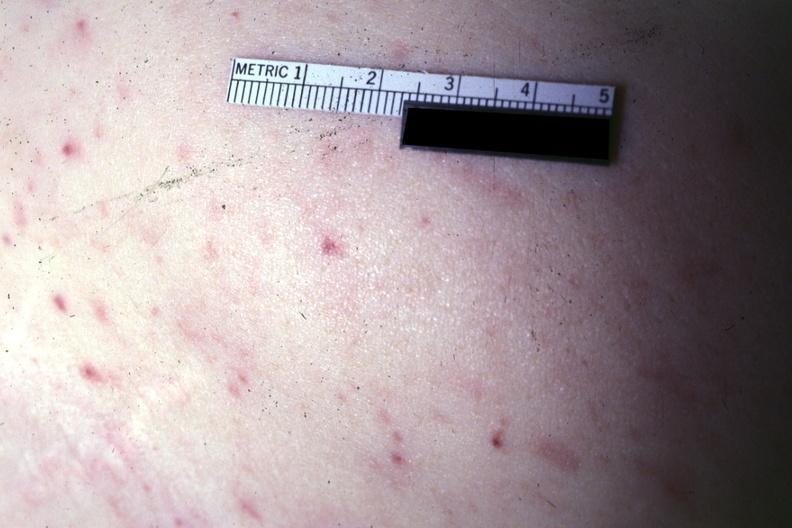what is present?
Answer the question using a single word or phrase. Petechiae 